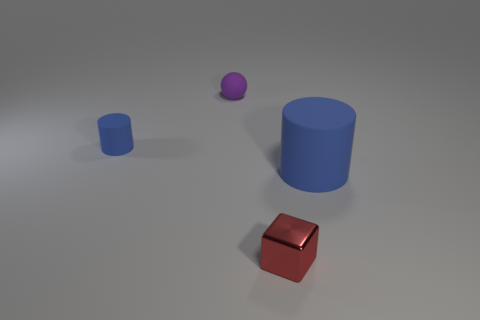Add 3 blocks. How many objects exist? 7 Subtract all spheres. How many objects are left? 3 Subtract all gray matte balls. Subtract all tiny blue objects. How many objects are left? 3 Add 4 cylinders. How many cylinders are left? 6 Add 4 tiny red metal blocks. How many tiny red metal blocks exist? 5 Subtract 0 brown balls. How many objects are left? 4 